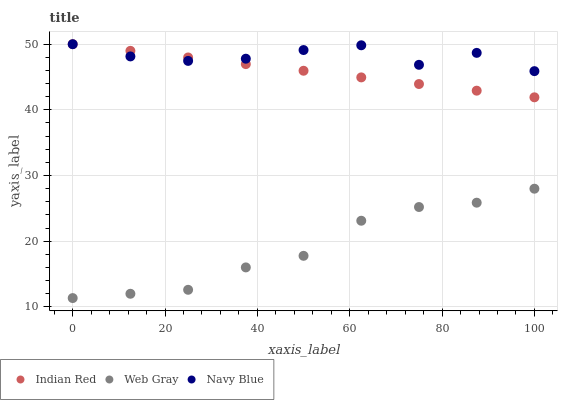Does Web Gray have the minimum area under the curve?
Answer yes or no. Yes. Does Navy Blue have the maximum area under the curve?
Answer yes or no. Yes. Does Indian Red have the minimum area under the curve?
Answer yes or no. No. Does Indian Red have the maximum area under the curve?
Answer yes or no. No. Is Indian Red the smoothest?
Answer yes or no. Yes. Is Navy Blue the roughest?
Answer yes or no. Yes. Is Web Gray the smoothest?
Answer yes or no. No. Is Web Gray the roughest?
Answer yes or no. No. Does Web Gray have the lowest value?
Answer yes or no. Yes. Does Indian Red have the lowest value?
Answer yes or no. No. Does Indian Red have the highest value?
Answer yes or no. Yes. Does Web Gray have the highest value?
Answer yes or no. No. Is Web Gray less than Navy Blue?
Answer yes or no. Yes. Is Navy Blue greater than Web Gray?
Answer yes or no. Yes. Does Navy Blue intersect Indian Red?
Answer yes or no. Yes. Is Navy Blue less than Indian Red?
Answer yes or no. No. Is Navy Blue greater than Indian Red?
Answer yes or no. No. Does Web Gray intersect Navy Blue?
Answer yes or no. No. 